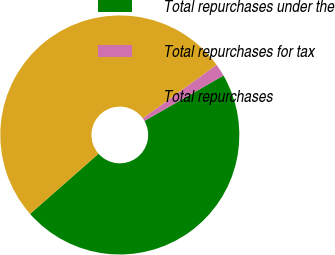Convert chart to OTSL. <chart><loc_0><loc_0><loc_500><loc_500><pie_chart><fcel>Total repurchases under the<fcel>Total repurchases for tax<fcel>Total repurchases<nl><fcel>46.81%<fcel>1.7%<fcel>51.49%<nl></chart> 